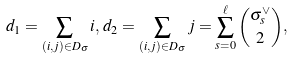Convert formula to latex. <formula><loc_0><loc_0><loc_500><loc_500>d _ { 1 } = \sum _ { ( i , j ) \in D _ { \sigma } } i , \, d _ { 2 } = \sum _ { ( i , j ) \in D _ { \sigma } } j = \sum _ { s = 0 } ^ { \ell } \binom { \sigma ^ { \vee } _ { s } } { 2 } ,</formula> 